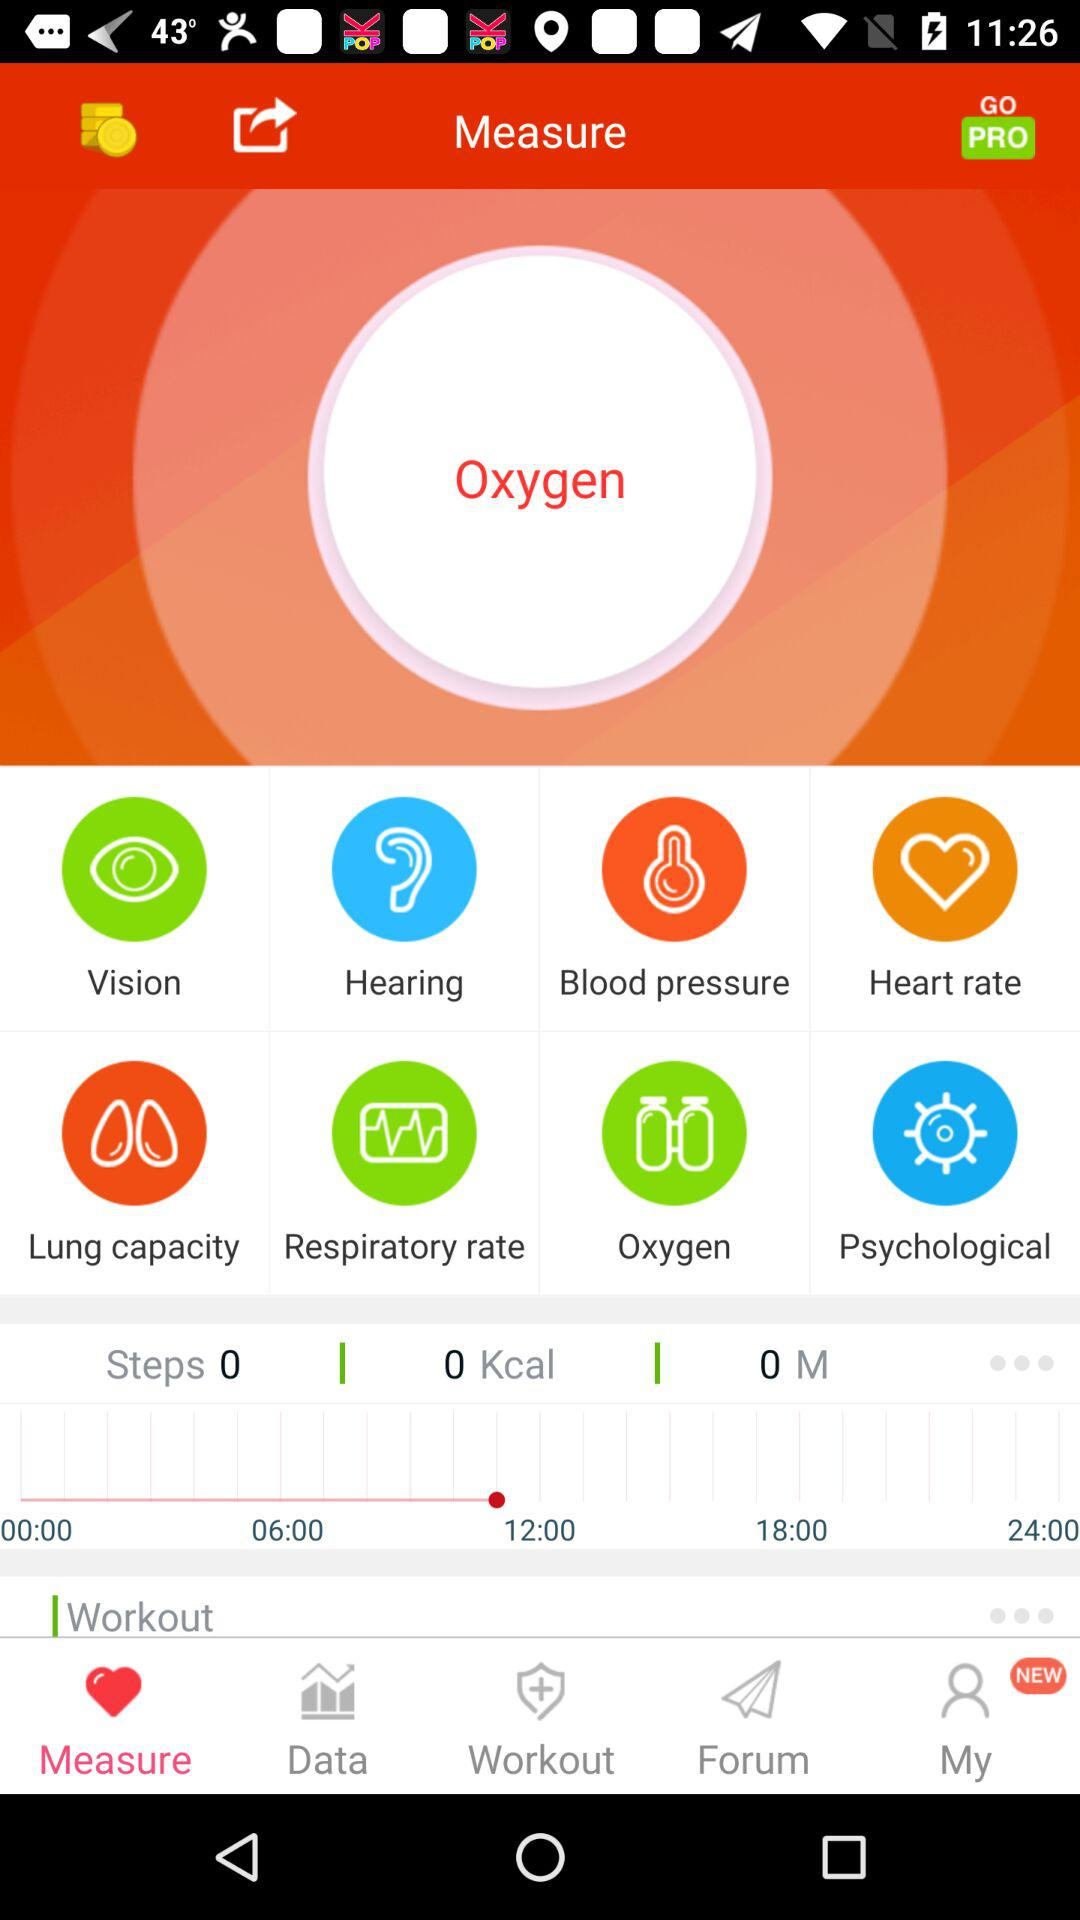What parameter is being measured currently? The parameter that is being measured currently is oxygen. 